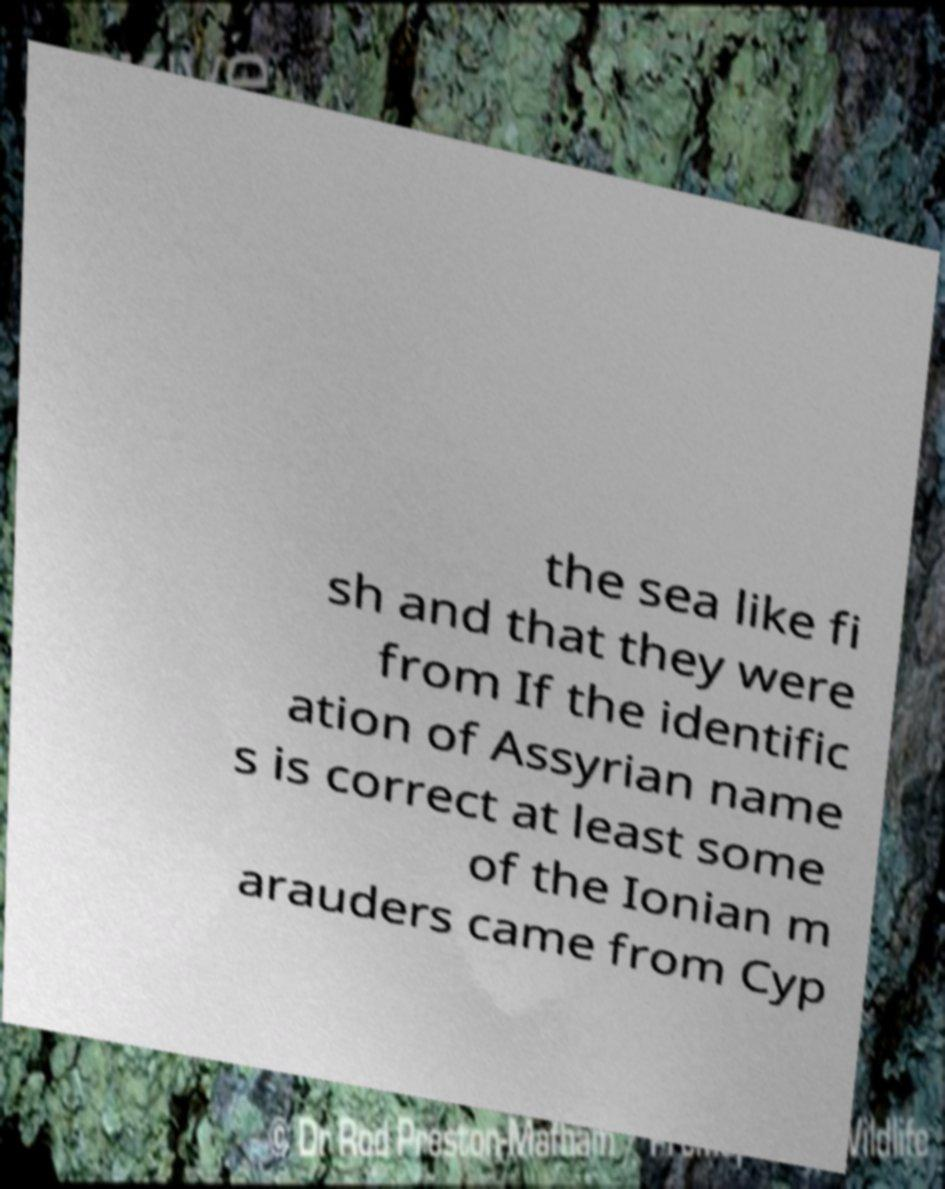Could you extract and type out the text from this image? the sea like fi sh and that they were from If the identific ation of Assyrian name s is correct at least some of the Ionian m arauders came from Cyp 